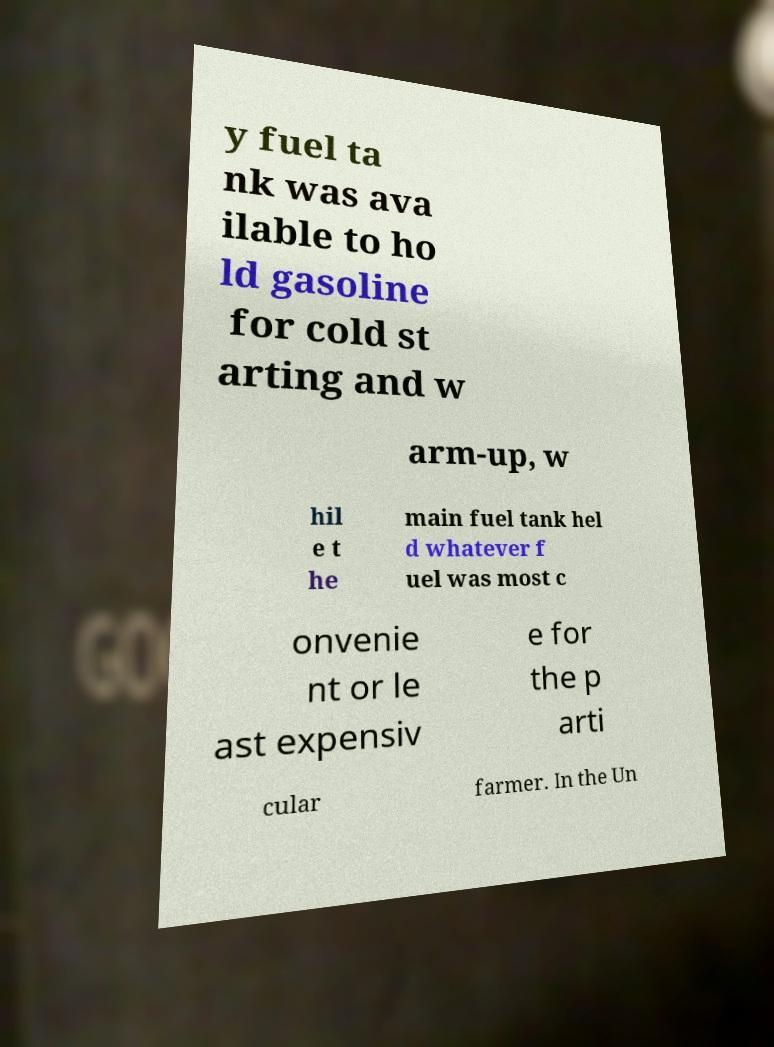Could you extract and type out the text from this image? y fuel ta nk was ava ilable to ho ld gasoline for cold st arting and w arm-up, w hil e t he main fuel tank hel d whatever f uel was most c onvenie nt or le ast expensiv e for the p arti cular farmer. In the Un 